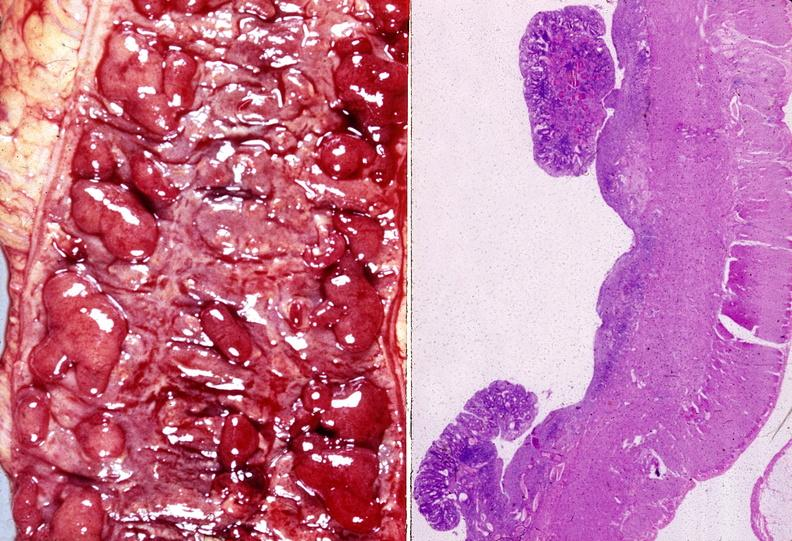does hemorrhage in newborn show colon, ulcerative colitis?
Answer the question using a single word or phrase. No 